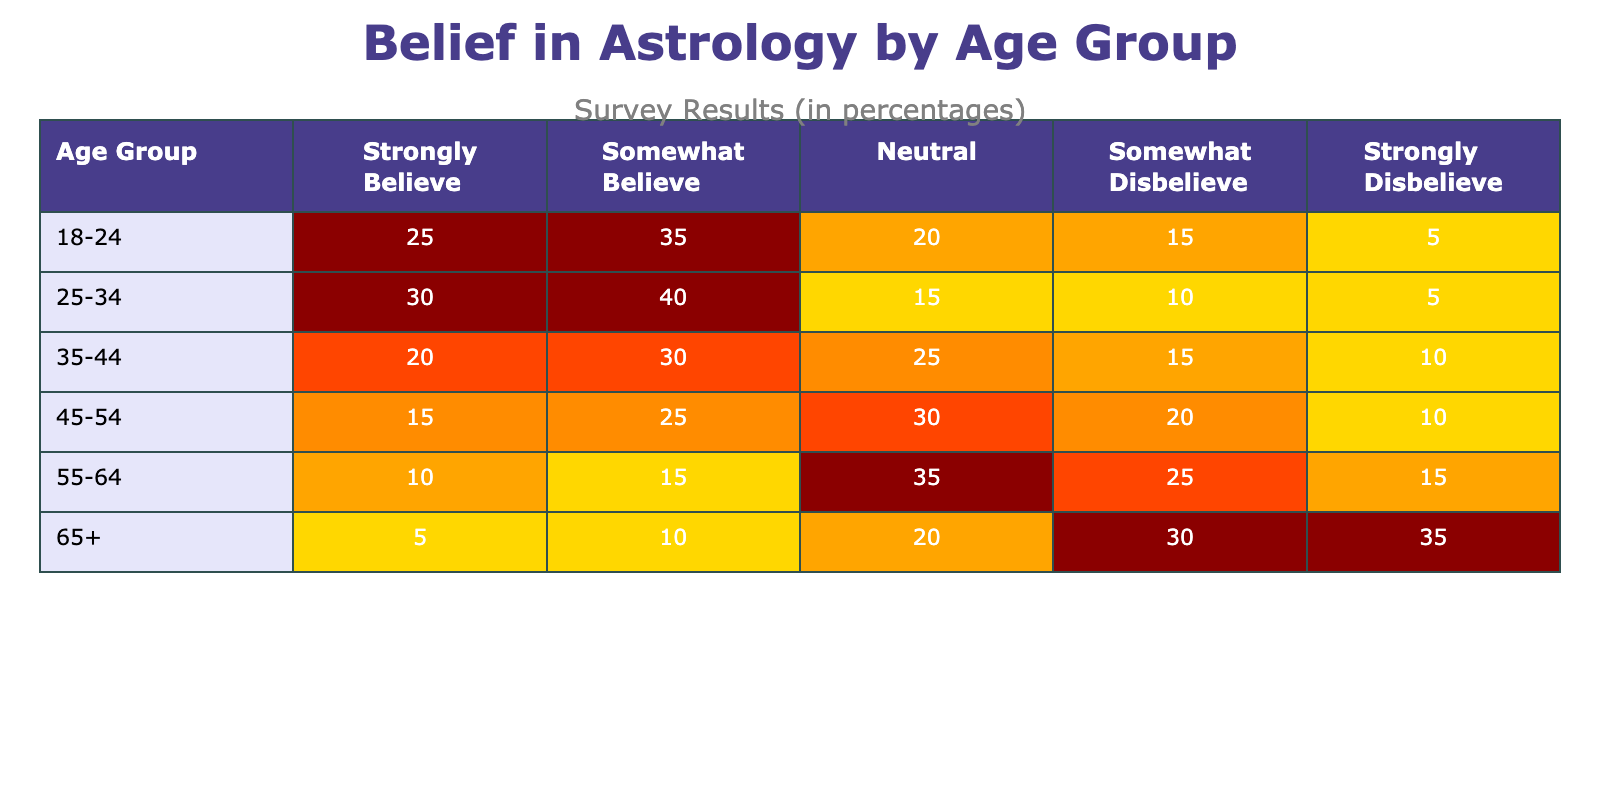What percentage of the 18-24 age group strongly believes in astrology? The value in the "Strongly Believe" column for the "18-24" age group is directly listed in the table, which shows 25.
Answer: 25 In which age group do the most people somewhat believe in astrology? The "Somewhat Believe" values in the table show that the highest percentage is in the "25-34" age group with 40%.
Answer: 25-34 What is the total percentage of people in the 55-64 age group who either believe or somewhat believe in astrology? We need to add the percentages for "Strongly Believe" and "Somewhat Believe" under the "55-64" age group: 10 + 15 = 25.
Answer: 25 Is it true that the percentage of strong disbelievers increases with age? Observing the "Strongly Disbelieve" column shows that percentages for older age groups (such as 65+) are higher compared to younger ones like 18-24, confirming this trend.
Answer: Yes What is the average percentage of people who are neutral towards astrology across all age groups? To find the average, we add the neutral percentages: 20 + 15 + 25 + 30 + 35 + 20 = 135. There are 6 age groups, so 135 divided by 6 equals 22.5.
Answer: 22.5 What percentage of the 45-54 age group disbelieves in astrology, either somewhat or strongly? We will sum both “Somewhat Disbelieve” (20) and “Strongly Disbelieve” (10) for the 45-54 age group, which totals 30.
Answer: 30 How does the belief in astrology change from the youngest age group to the oldest age group in terms of strong belief? The "Strongly Believe" percentages decrease from 25 (18-24) to 5 (65+), indicating a clear decline in strong belief as the age increases.
Answer: Decrease In the 35-44 age group, what is the difference between the percentage of those who somewhat believe and those who somewhat disbelieve? For the 35-44 age group, we take "Somewhat Believe" (30) and "Somewhat Disbelieve" (15). Subtracting gives us 30 - 15 = 15.
Answer: 15 